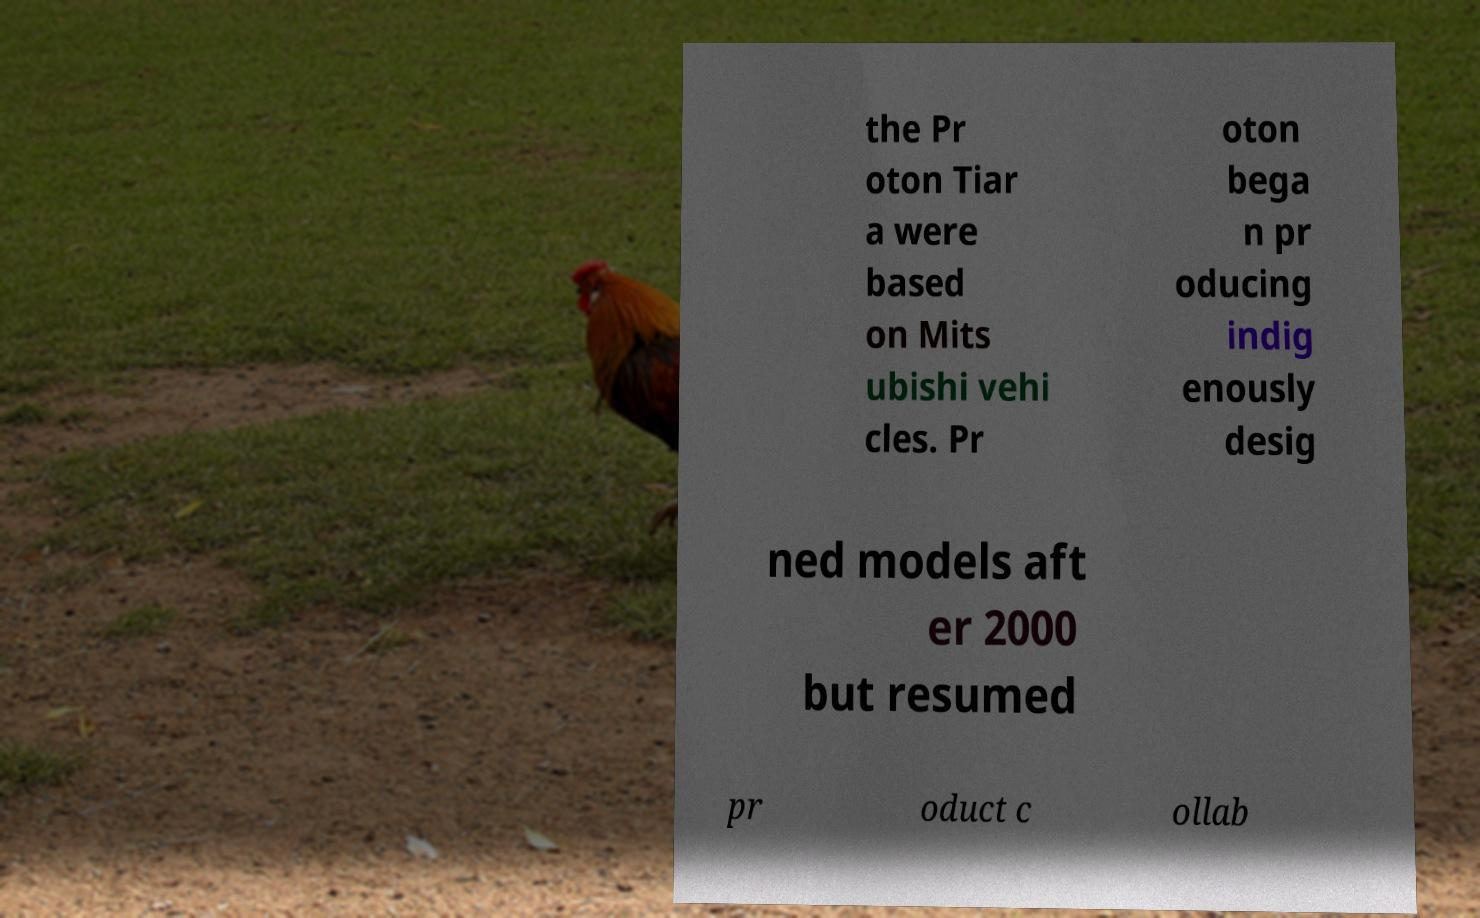Can you accurately transcribe the text from the provided image for me? the Pr oton Tiar a were based on Mits ubishi vehi cles. Pr oton bega n pr oducing indig enously desig ned models aft er 2000 but resumed pr oduct c ollab 